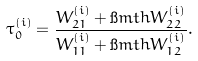Convert formula to latex. <formula><loc_0><loc_0><loc_500><loc_500>\tau ^ { ( i ) } _ { 0 } = \frac { W ^ { ( i ) } _ { 2 1 } + \i m t h W ^ { ( i ) } _ { 2 2 } } { W ^ { ( i ) } _ { 1 1 } + \i m t h W ^ { ( i ) } _ { 1 2 } } .</formula> 